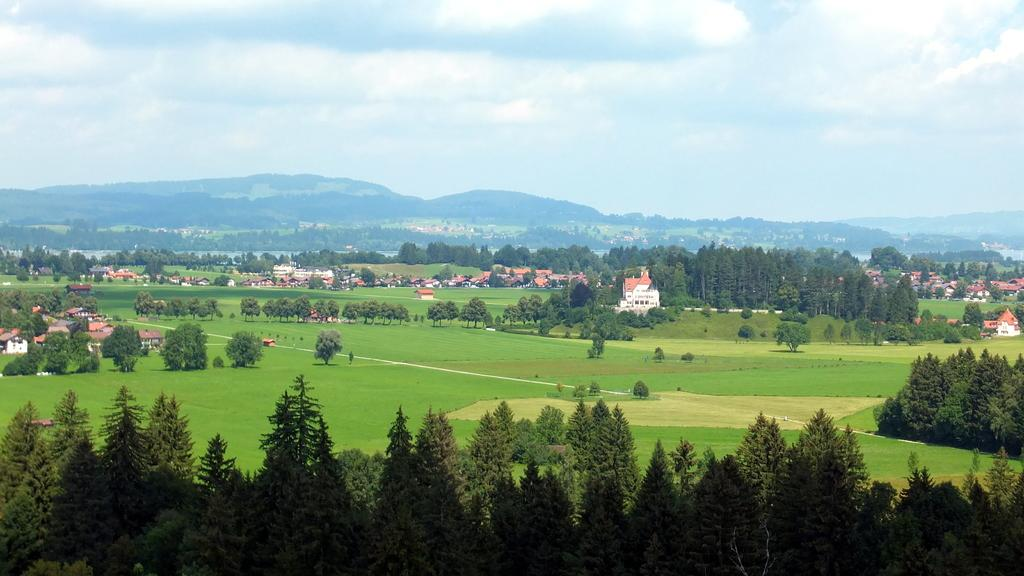What type of view is shown in the image? The image is an outside view. What can be seen in the image besides the sky? There are many trees, buildings, grass, and hills visible in the image. What is the terrain like in the image? The terrain includes grass and hills. What is visible celestial body is present in the sky? The sky is visible at the top of the image, and clouds are present. What type of machine is being used to clear the grass in the image? There is no machine present in the image; it shows grass in its natural state. 